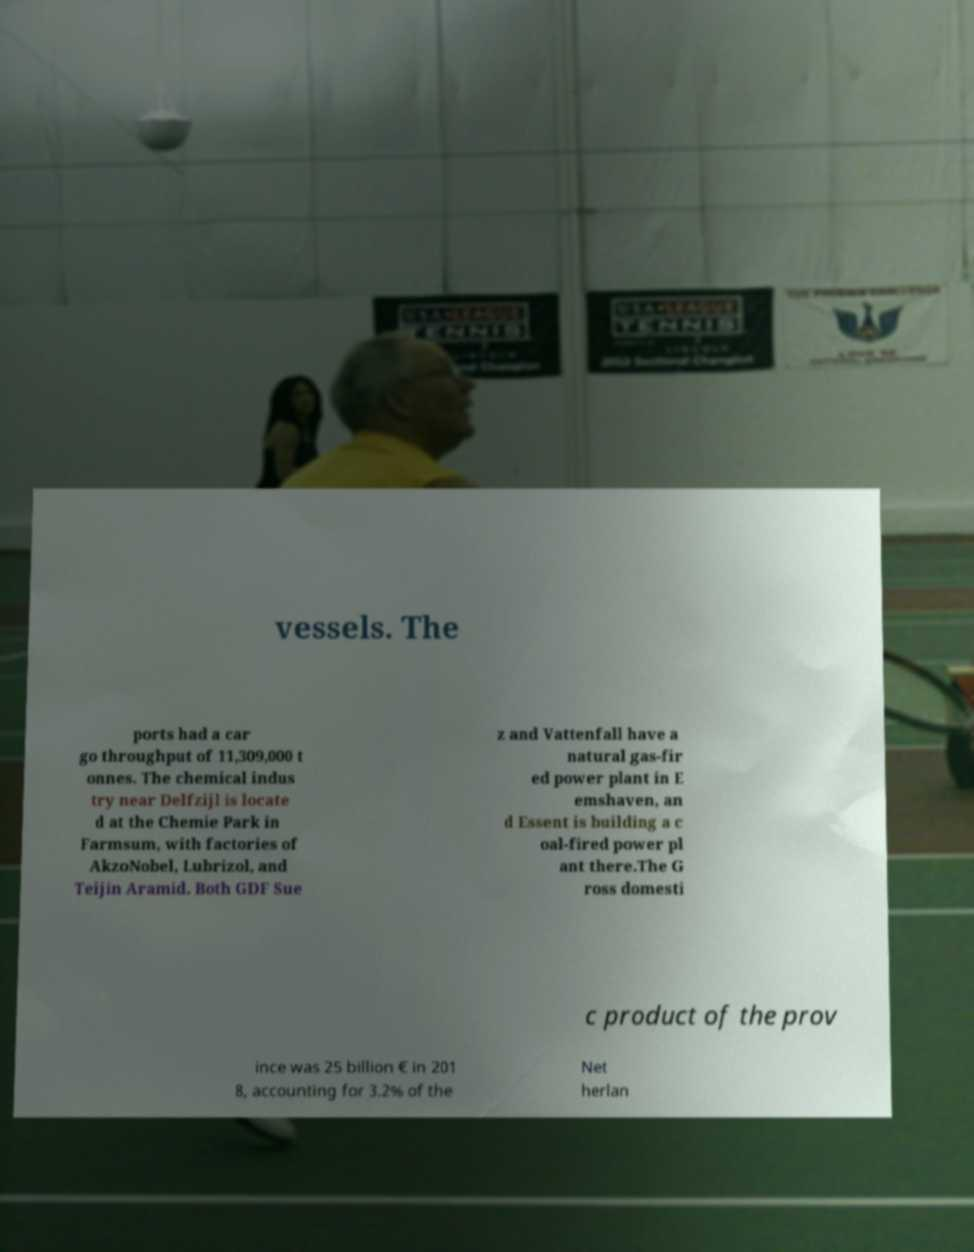There's text embedded in this image that I need extracted. Can you transcribe it verbatim? vessels. The ports had a car go throughput of 11,309,000 t onnes. The chemical indus try near Delfzijl is locate d at the Chemie Park in Farmsum, with factories of AkzoNobel, Lubrizol, and Teijin Aramid. Both GDF Sue z and Vattenfall have a natural gas-fir ed power plant in E emshaven, an d Essent is building a c oal-fired power pl ant there.The G ross domesti c product of the prov ince was 25 billion € in 201 8, accounting for 3.2% of the Net herlan 